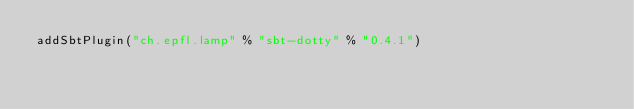<code> <loc_0><loc_0><loc_500><loc_500><_Scala_>addSbtPlugin("ch.epfl.lamp" % "sbt-dotty" % "0.4.1")
</code> 